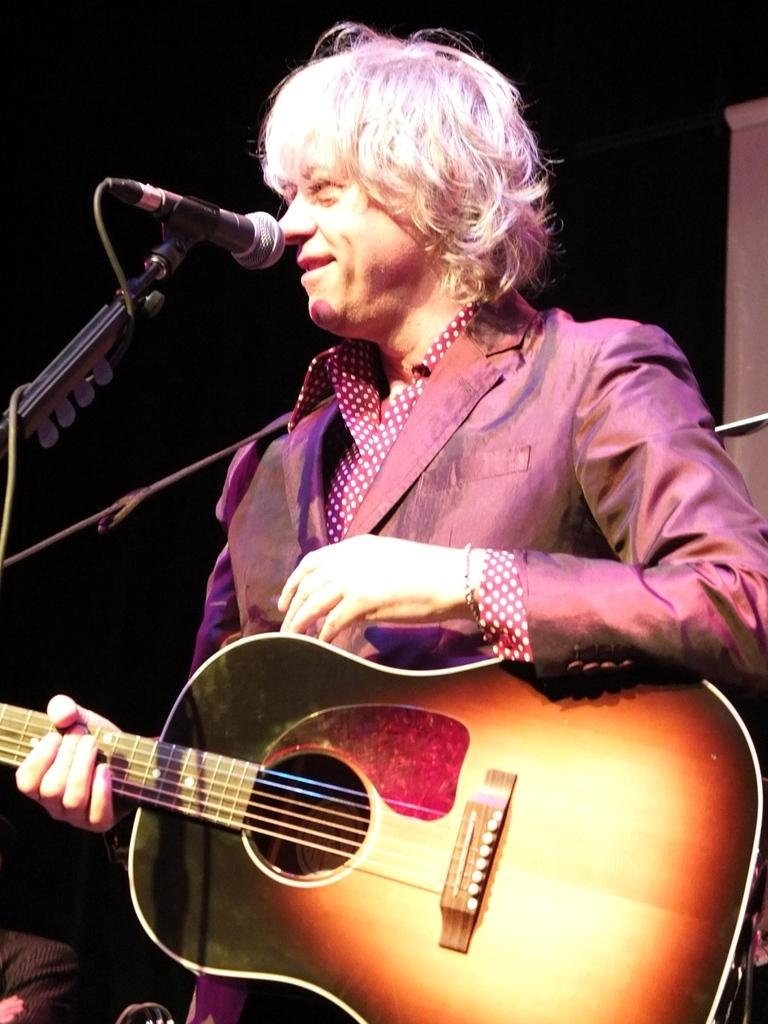What is the main subject of the image? There is a person in the image. What is the person doing in the image? The person is standing and smiling. What object is the person holding in the image? The person is holding a guitar. What equipment is present for amplifying sound in the image? There is a microphone and a microphone stand in the image. How many babies are visible in the image? There are no babies present in the image. What type of profit can be seen in the image? There is no mention of profit in the image; it features a person holding a guitar and standing near a microphone and microphone stand. 